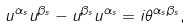Convert formula to latex. <formula><loc_0><loc_0><loc_500><loc_500>u ^ { \alpha _ { s } } u ^ { \beta _ { s } } - u ^ { \beta _ { s } } u ^ { \alpha _ { s } } = i \theta ^ { \alpha _ { s } \beta _ { s } } ,</formula> 